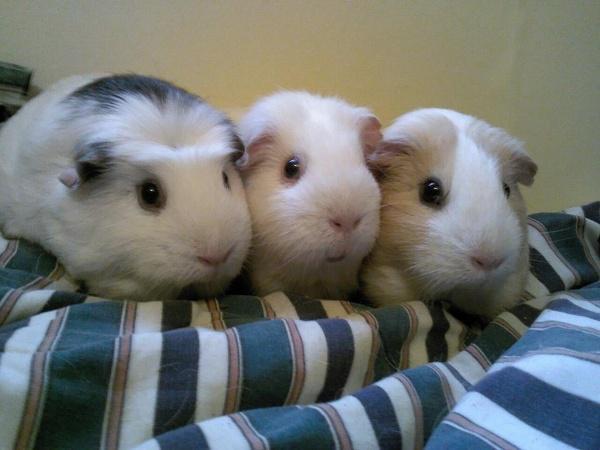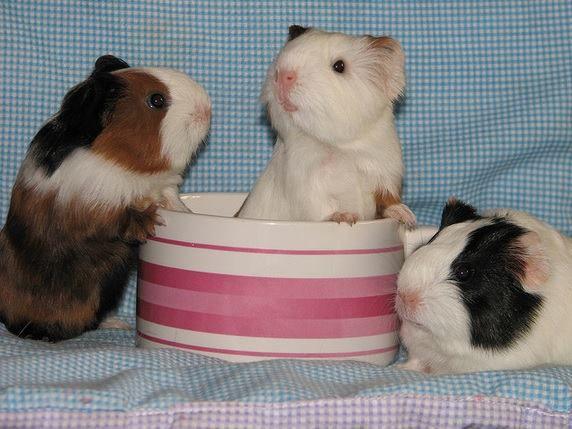The first image is the image on the left, the second image is the image on the right. Evaluate the accuracy of this statement regarding the images: "There are six mammals huddled in groups of three.". Is it true? Answer yes or no. No. 